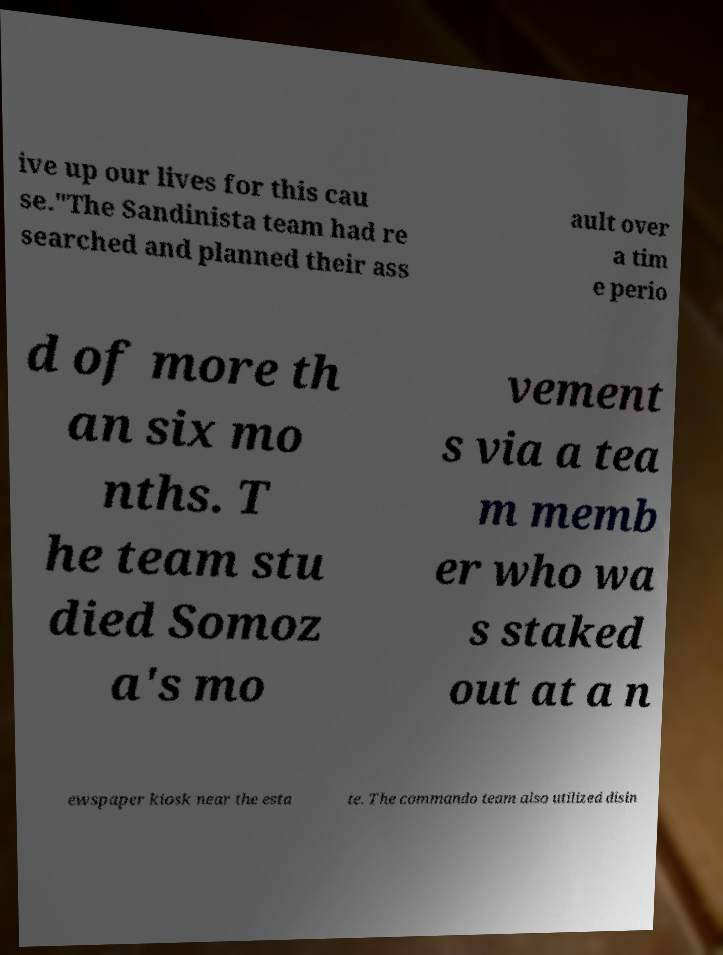Please read and relay the text visible in this image. What does it say? ive up our lives for this cau se."The Sandinista team had re searched and planned their ass ault over a tim e perio d of more th an six mo nths. T he team stu died Somoz a's mo vement s via a tea m memb er who wa s staked out at a n ewspaper kiosk near the esta te. The commando team also utilized disin 